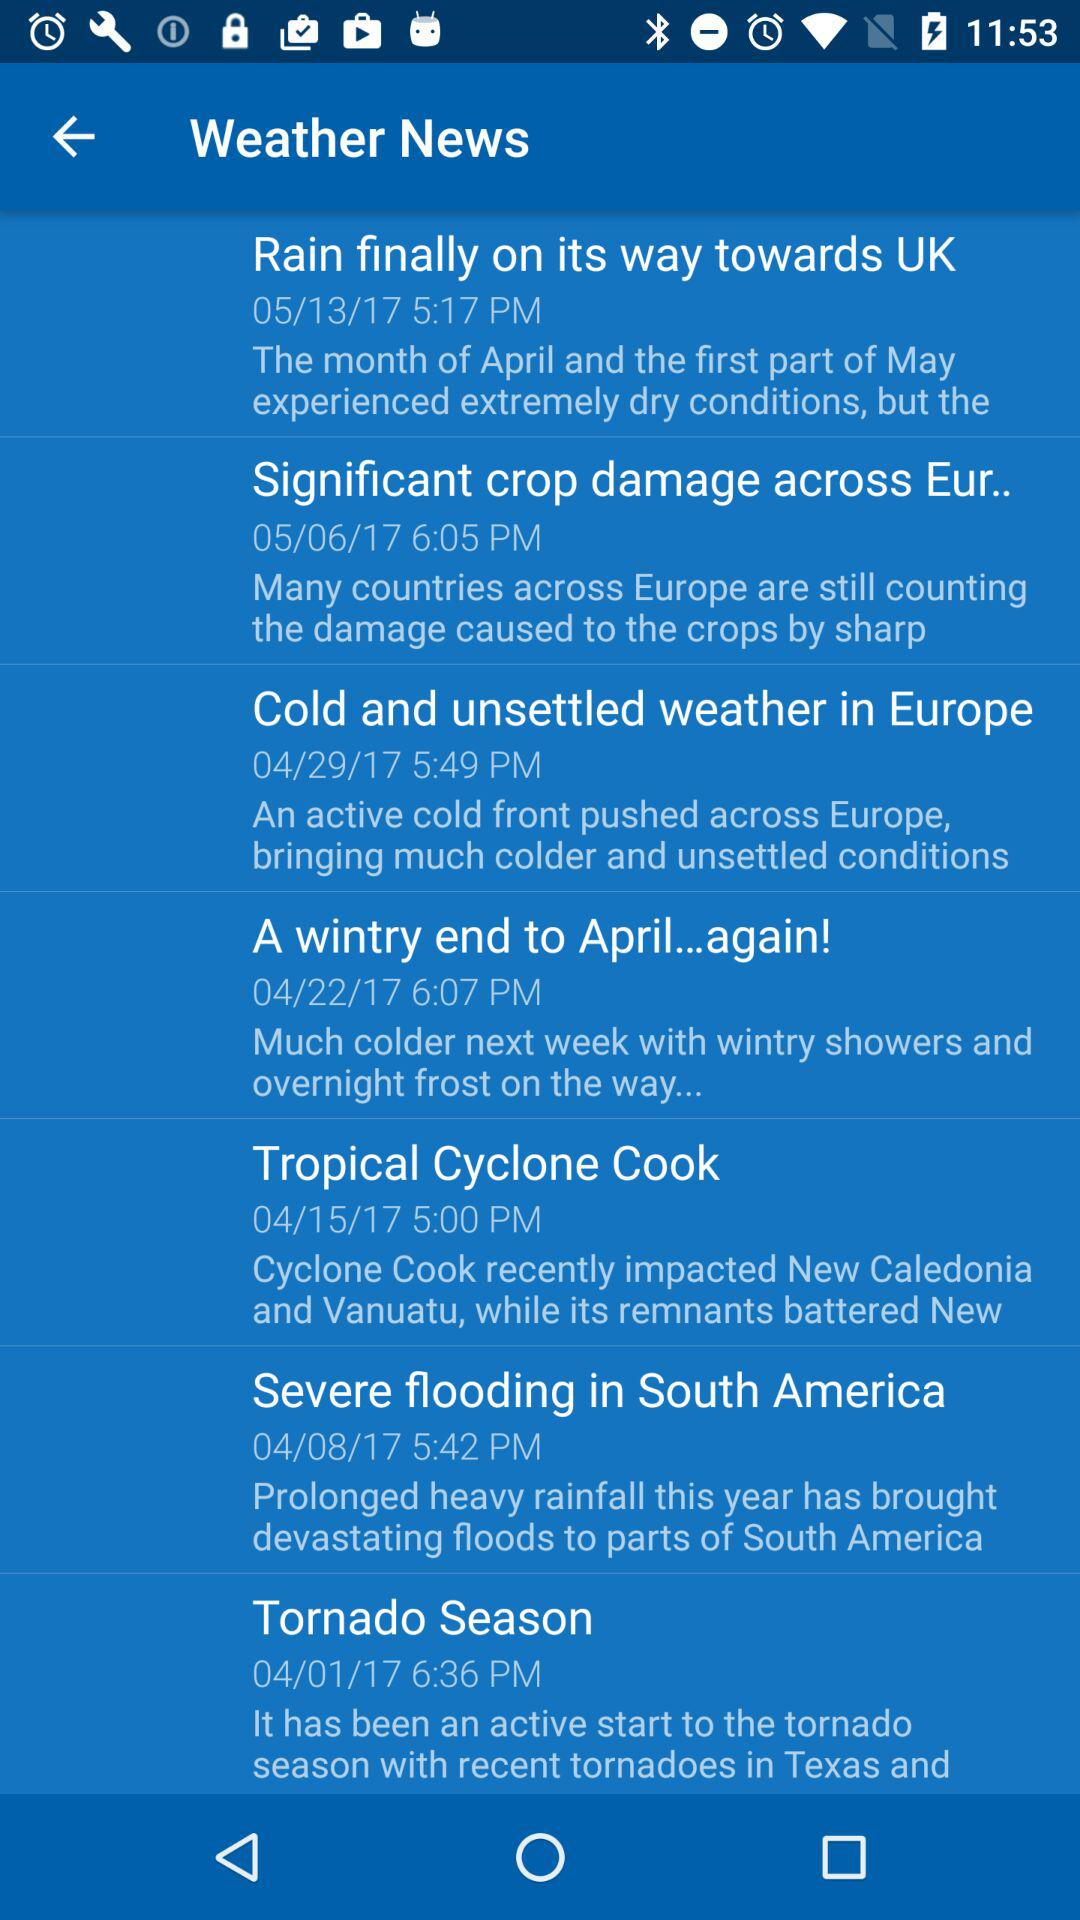When was the "Tropical Cyclone Cook" news posted? The news was posted on April 15, 2017 at 5:00 PM. 